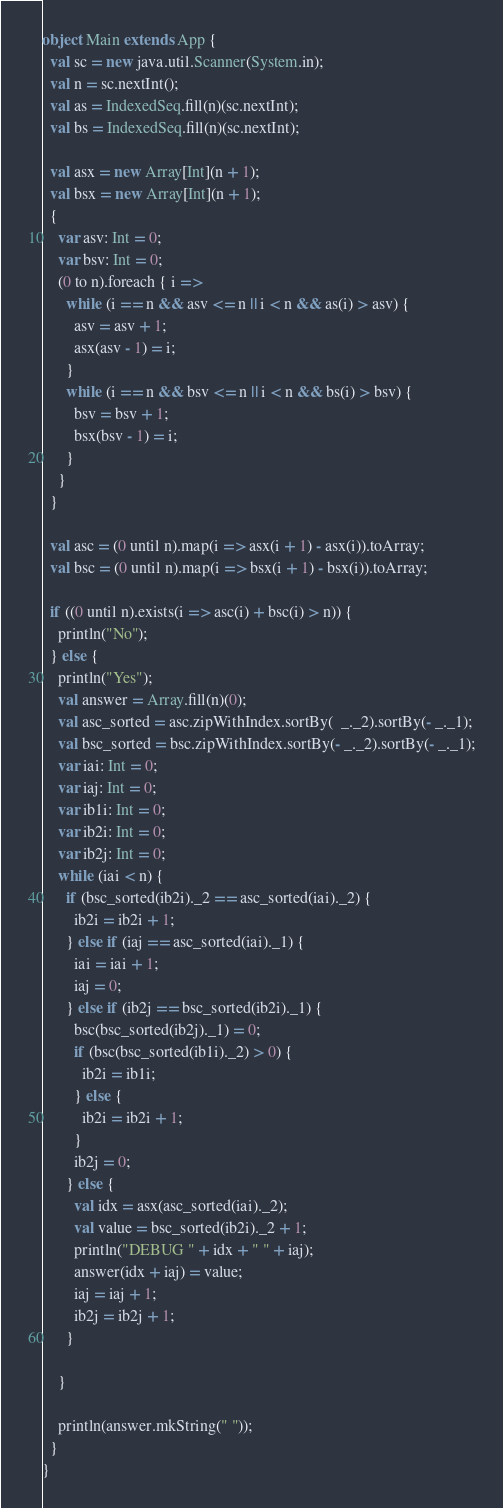<code> <loc_0><loc_0><loc_500><loc_500><_Scala_>object Main extends App {
  val sc = new java.util.Scanner(System.in);
  val n = sc.nextInt();
  val as = IndexedSeq.fill(n)(sc.nextInt);
  val bs = IndexedSeq.fill(n)(sc.nextInt);

  val asx = new Array[Int](n + 1);
  val bsx = new Array[Int](n + 1);
  {
    var asv: Int = 0;
    var bsv: Int = 0;
    (0 to n).foreach { i =>
      while (i == n && asv <= n || i < n && as(i) > asv) {
        asv = asv + 1;
        asx(asv - 1) = i;
      }
      while (i == n && bsv <= n || i < n && bs(i) > bsv) {
        bsv = bsv + 1;
        bsx(bsv - 1) = i;
      }
    }
  }

  val asc = (0 until n).map(i => asx(i + 1) - asx(i)).toArray;
  val bsc = (0 until n).map(i => bsx(i + 1) - bsx(i)).toArray;

  if ((0 until n).exists(i => asc(i) + bsc(i) > n)) {
    println("No");
  } else {
    println("Yes");
    val answer = Array.fill(n)(0);
    val asc_sorted = asc.zipWithIndex.sortBy(  _._2).sortBy(- _._1);
    val bsc_sorted = bsc.zipWithIndex.sortBy(- _._2).sortBy(- _._1);
    var iai: Int = 0;
    var iaj: Int = 0;
    var ib1i: Int = 0;
    var ib2i: Int = 0;
    var ib2j: Int = 0;
    while (iai < n) {
      if (bsc_sorted(ib2i)._2 == asc_sorted(iai)._2) {
        ib2i = ib2i + 1;
      } else if (iaj == asc_sorted(iai)._1) {
        iai = iai + 1;
        iaj = 0;
      } else if (ib2j == bsc_sorted(ib2i)._1) {
        bsc(bsc_sorted(ib2j)._1) = 0;
        if (bsc(bsc_sorted(ib1i)._2) > 0) {
          ib2i = ib1i;
        } else {
          ib2i = ib2i + 1;
        }
        ib2j = 0;
      } else {
        val idx = asx(asc_sorted(iai)._2);
        val value = bsc_sorted(ib2i)._2 + 1;
        println("DEBUG " + idx + " " + iaj);
        answer(idx + iaj) = value;
        iaj = iaj + 1;
        ib2j = ib2j + 1;
      }

    }
    
    println(answer.mkString(" "));
  }
}
</code> 